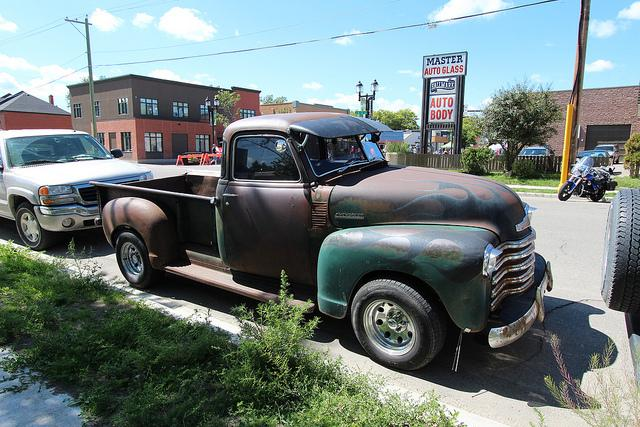What sort of business are the autos in all likelihood closest to? Please explain your reasoning. auto repair. The sign on the business across the street references both glass and body work available for cars. 